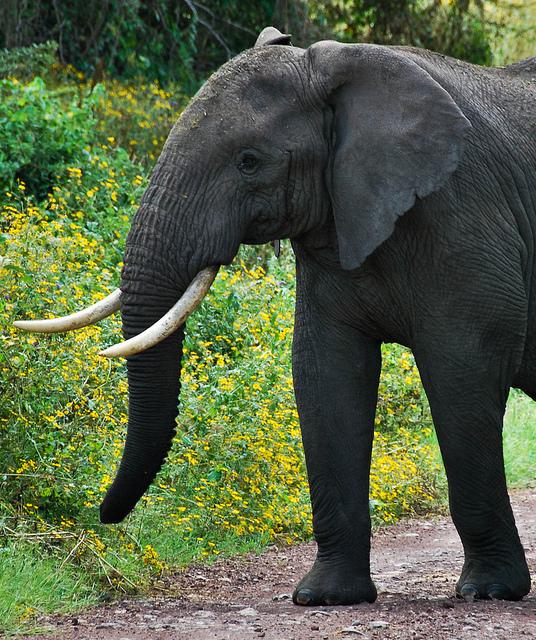Does the elephant have large tusks?
Be succinct. Yes. What type of animal is this?
Be succinct. Elephant. What protrudes from under his trunk?
Keep it brief. Tusks. Are the flowers in bloom?
Write a very short answer. Yes. 